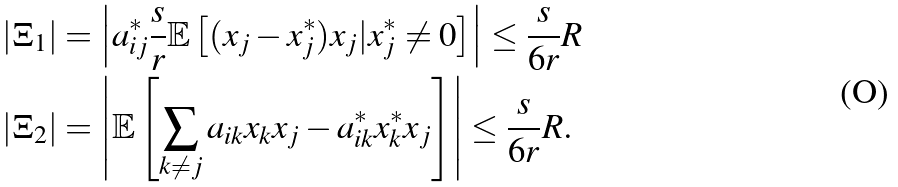<formula> <loc_0><loc_0><loc_500><loc_500>| \Xi _ { 1 } | & = \left | a _ { i j } ^ { * } \frac { s } { r } \mathbb { E } \left [ ( x _ { j } - x _ { j } ^ { * } ) x _ { j } | x ^ { * } _ { j } \neq 0 \right ] \right | \leq \frac { s } { 6 r } R \\ | \Xi _ { 2 } | & = \left | \mathbb { E } \left [ \sum _ { k \neq j } a _ { i k } x _ { k } x _ { j } - a ^ { * } _ { i k } x _ { k } ^ { * } x _ { j } \right ] \right | \leq \frac { s } { 6 r } R .</formula> 